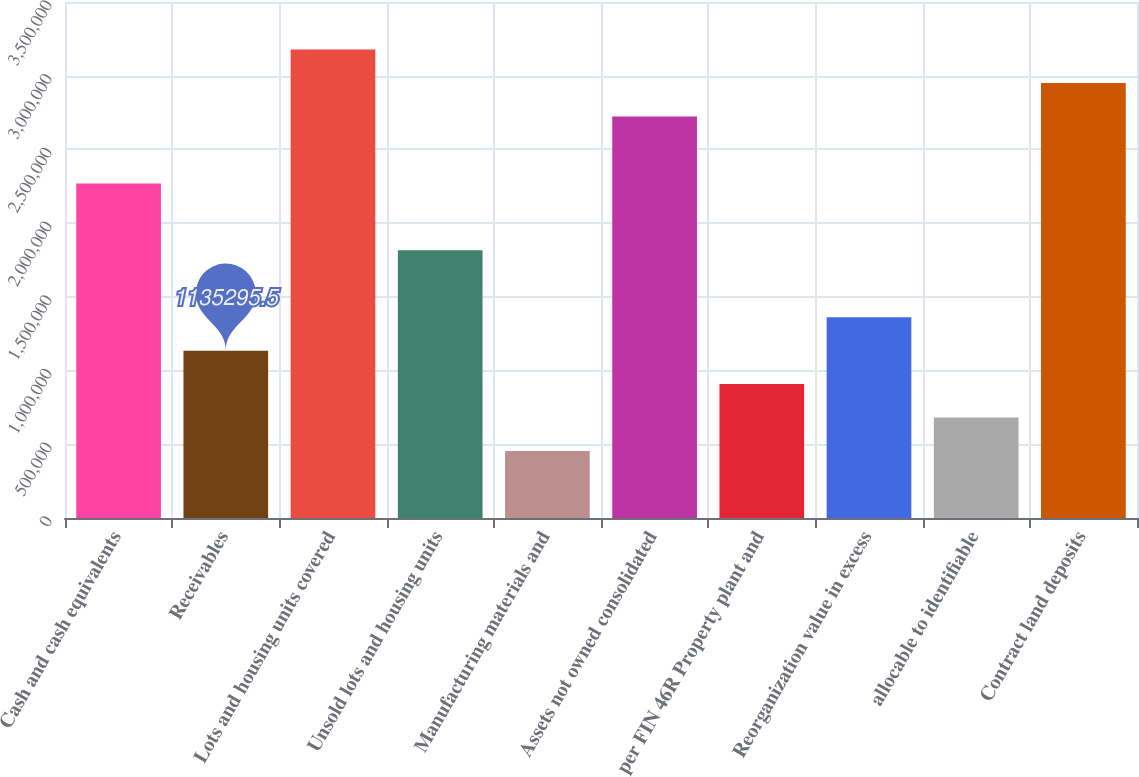<chart> <loc_0><loc_0><loc_500><loc_500><bar_chart><fcel>Cash and cash equivalents<fcel>Receivables<fcel>Lots and housing units covered<fcel>Unsold lots and housing units<fcel>Manufacturing materials and<fcel>Assets not owned consolidated<fcel>per FIN 46R Property plant and<fcel>Reorganization value in excess<fcel>allocable to identifiable<fcel>Contract land deposits<nl><fcel>2.26959e+06<fcel>1.1353e+06<fcel>3.17702e+06<fcel>1.81587e+06<fcel>454720<fcel>2.7233e+06<fcel>908437<fcel>1.36215e+06<fcel>681578<fcel>2.95016e+06<nl></chart> 